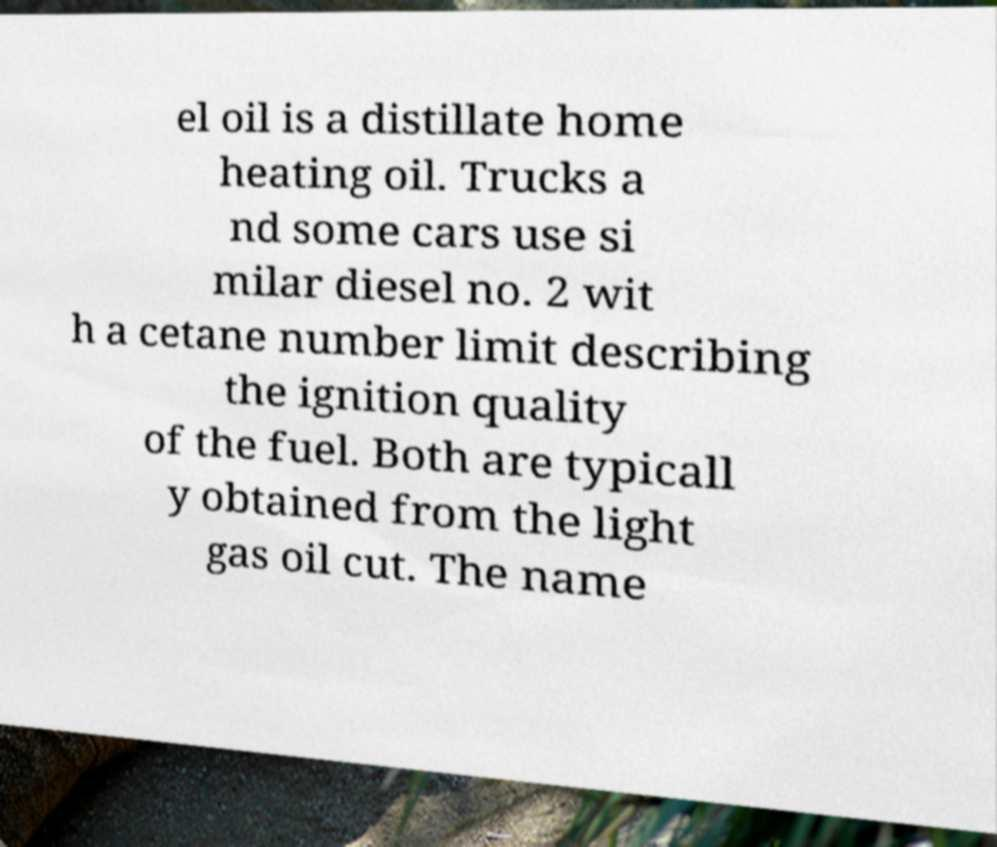Could you extract and type out the text from this image? el oil is a distillate home heating oil. Trucks a nd some cars use si milar diesel no. 2 wit h a cetane number limit describing the ignition quality of the fuel. Both are typicall y obtained from the light gas oil cut. The name 